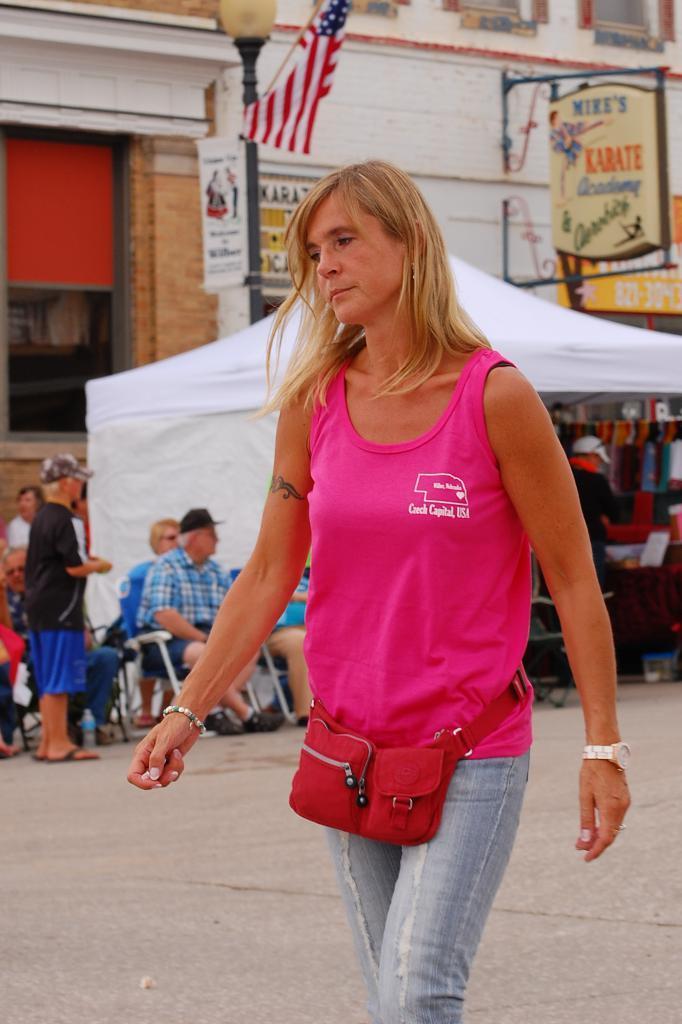Describe this image in one or two sentences. In this image we can see a woman wearing the bag and walking on the road. In the background, we can see the tent. We can also see the people sitting on the chairs. There is a man standing. We can also see the building, hoarding, light pole with some banner and also the flag. 